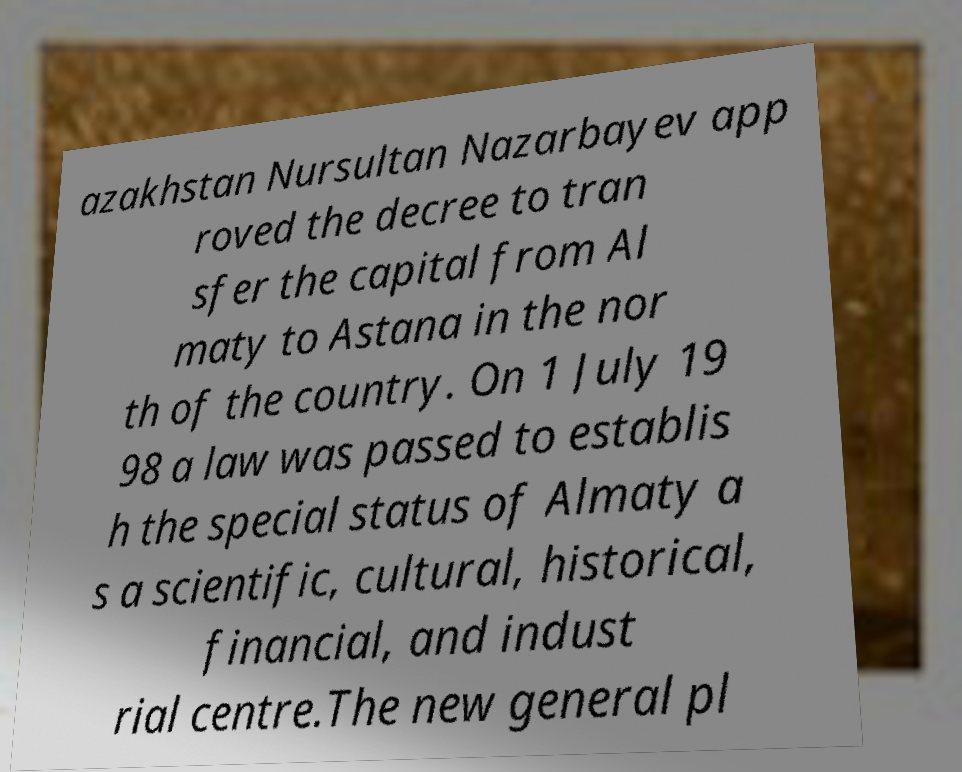There's text embedded in this image that I need extracted. Can you transcribe it verbatim? azakhstan Nursultan Nazarbayev app roved the decree to tran sfer the capital from Al maty to Astana in the nor th of the country. On 1 July 19 98 a law was passed to establis h the special status of Almaty a s a scientific, cultural, historical, financial, and indust rial centre.The new general pl 